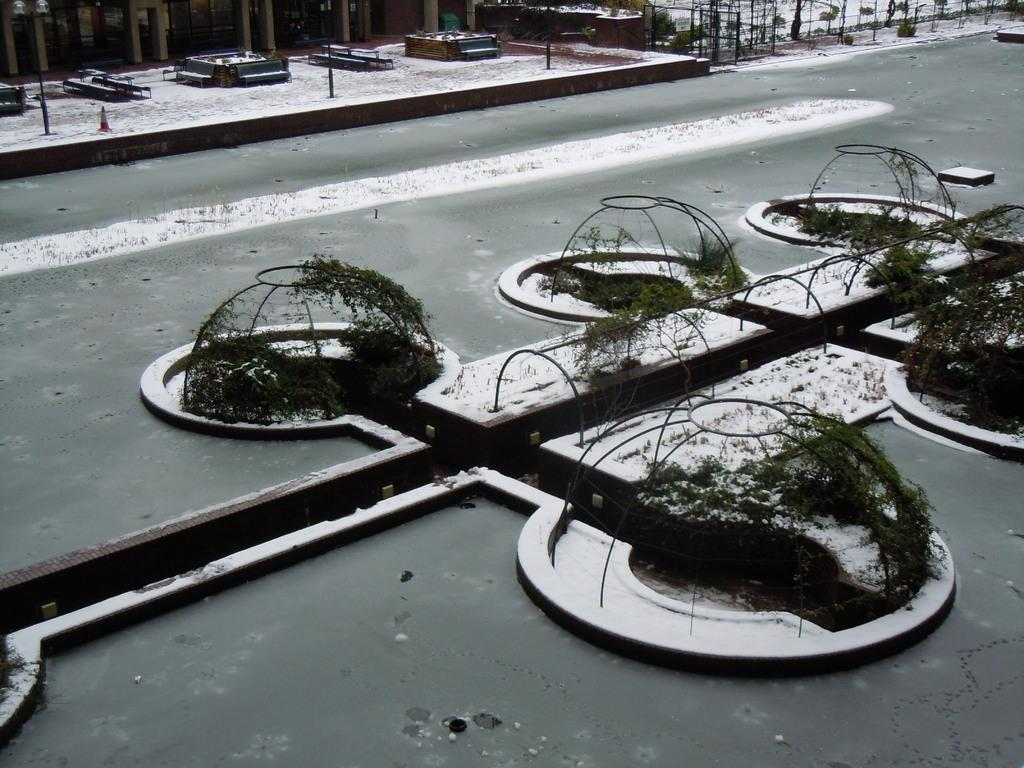What can be seen in the image that is used for cooking? There are grills in the image that are used for cooking. What type of vegetation is present in the image? There are plants in the image. What is the weather condition in the image? There is snow in the image, indicating a cold weather condition. What objects can be seen in the background of the image? Metal rods are visible in the background of the image. What type of bells can be heard ringing in the image? There are no bells present in the image, and therefore no sound can be heard. How many cats are visible in the image? There are no cats present in the image. 